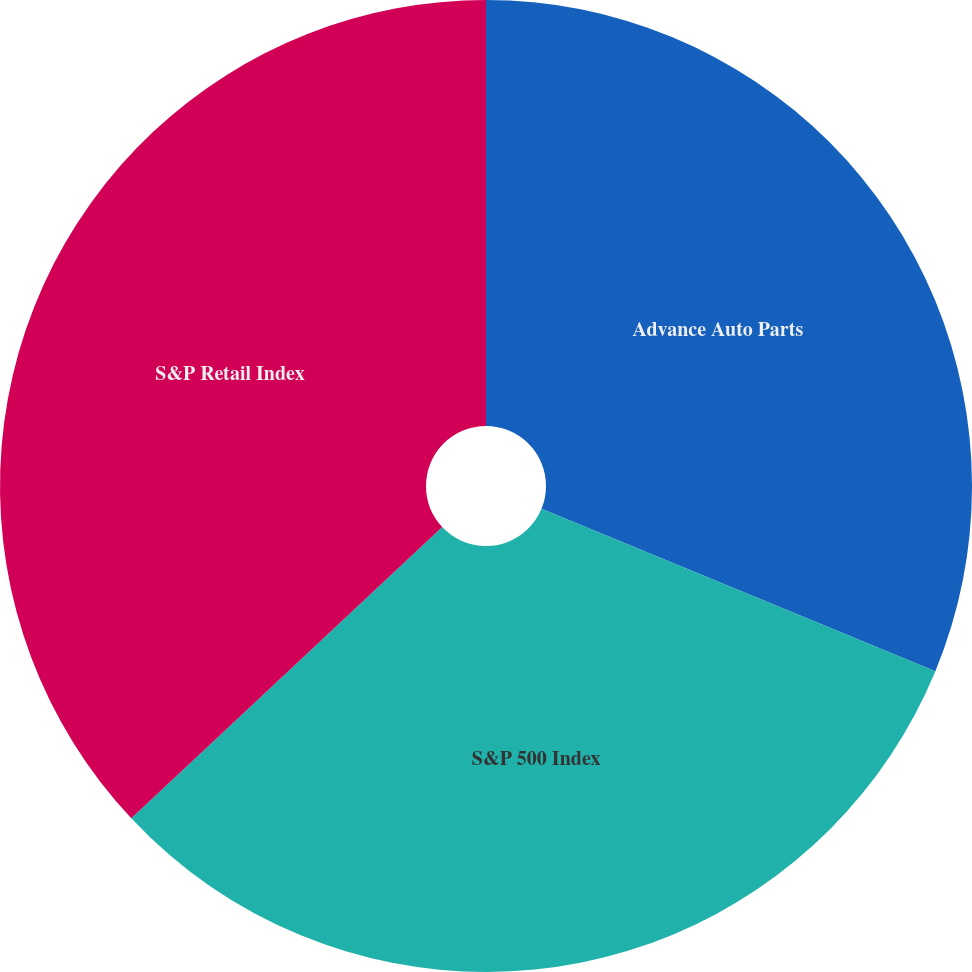Convert chart to OTSL. <chart><loc_0><loc_0><loc_500><loc_500><pie_chart><fcel>Advance Auto Parts<fcel>S&P 500 Index<fcel>S&P Retail Index<nl><fcel>31.22%<fcel>31.8%<fcel>36.98%<nl></chart> 